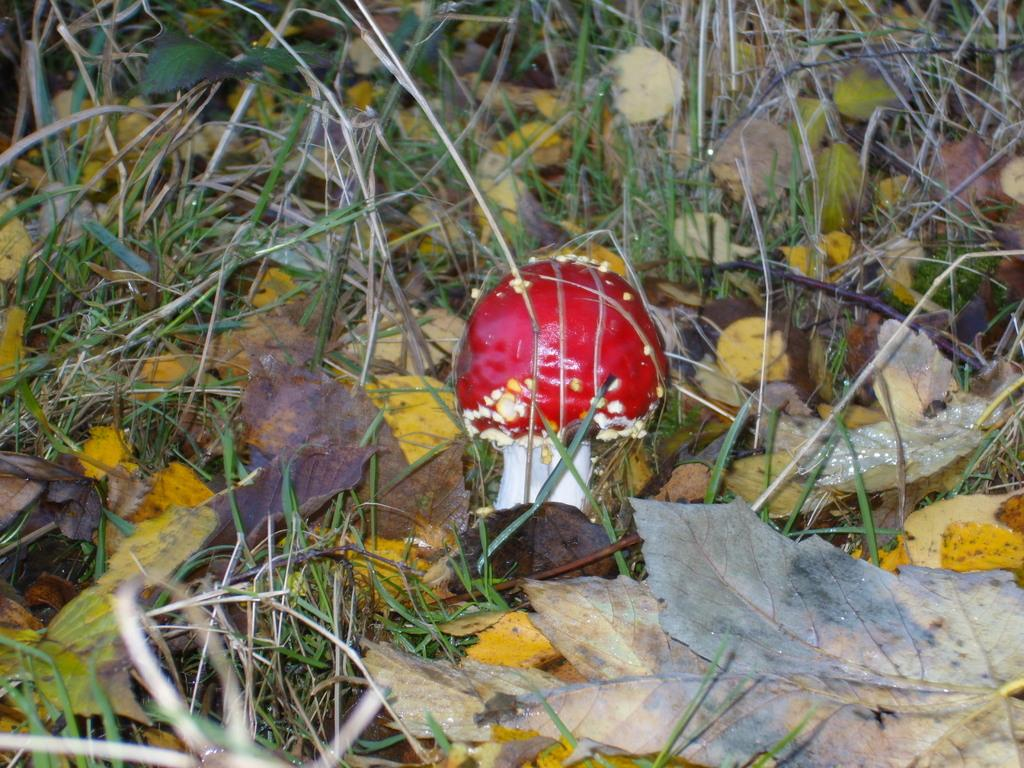What celestial bodies are depicted in the image? There are planets in the image. Can you describe any other objects or features in the image? Yes, there is a red mushroom in the image. How many family members can be seen in the image? There are no family members present in the image; it features planets and a red mushroom. What type of egg is visible in the image? There are no eggs present in the image. 